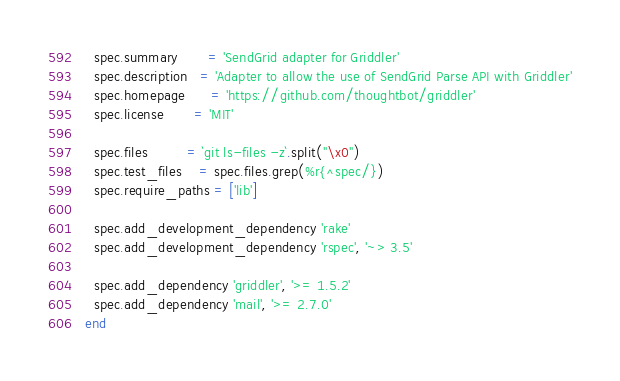<code> <loc_0><loc_0><loc_500><loc_500><_Ruby_>  spec.summary       = 'SendGrid adapter for Griddler'
  spec.description   = 'Adapter to allow the use of SendGrid Parse API with Griddler'
  spec.homepage      = 'https://github.com/thoughtbot/griddler'
  spec.license       = 'MIT'

  spec.files         = `git ls-files -z`.split("\x0")
  spec.test_files    = spec.files.grep(%r{^spec/})
  spec.require_paths = ['lib']

  spec.add_development_dependency 'rake'
  spec.add_development_dependency 'rspec', '~> 3.5'

  spec.add_dependency 'griddler', '>= 1.5.2'
  spec.add_dependency 'mail', '>= 2.7.0'
end
</code> 